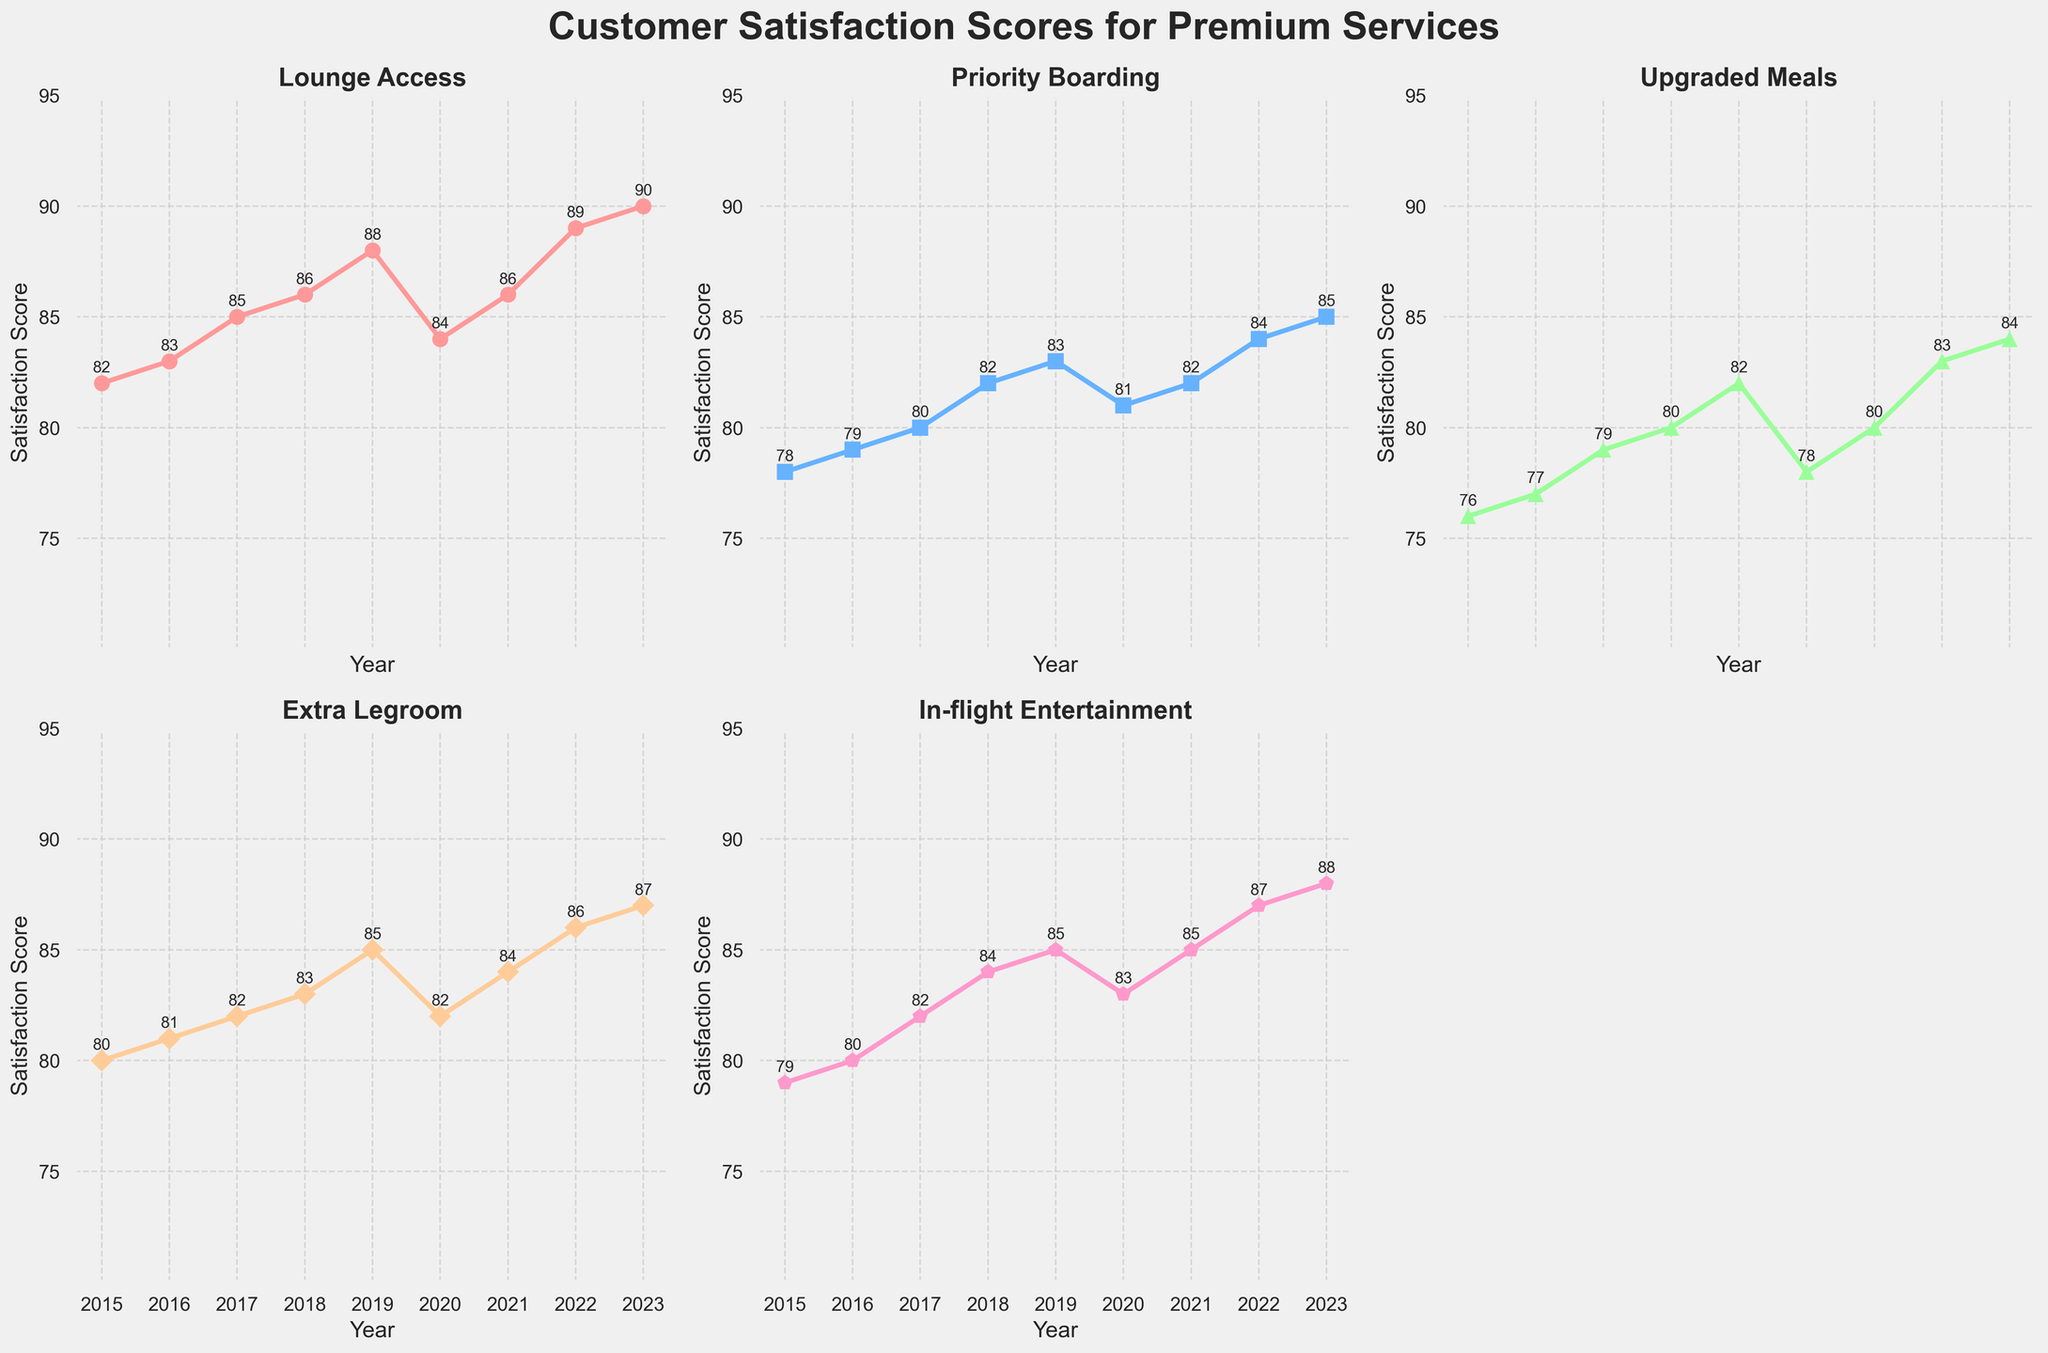What's the highest customer satisfaction score achieved for Lounge Access? In the chart, find the plot for Lounge Access and look for the highest point over the years. The highest customer satisfaction score for Lounge Access is labeled as 90 in 2023.
Answer: 90 How did the customer satisfaction score for Priority Boarding change from 2019 to 2020? In the chart, locate the Priority Boarding plot. Find the score for the years 2019 and 2020. The score decreased from 83 in 2019 to 81 in 2020.
Answer: Decreased by 2 Which premium service had the highest improvement in customer satisfaction score between 2015 and 2023? Check the starting and ending scores for each service from 2015 to 2023. Calculate the improvement for each service: Lounge Access (90-82=8), Priority Boarding (85-78=7), Upgraded Meals (84-76=8), Extra Legroom (87-80=7), In-flight Entertainment (88-79=9). The highest improvement is for In-flight Entertainment.
Answer: In-flight Entertainment In which year did Extra Legroom see the lowest satisfaction score? Identify the Extra Legroom plot and look for the lowest point in the chart. The lowest satisfaction score for Extra Legroom is 80 in 2015.
Answer: 2015 Which two services had the closest customer satisfaction scores in 2017? Locate the satisfaction scores for all services in 2017. Check differences between them: Lounge Access (85), Priority Boarding (80), Upgraded Meals (79), Extra Legroom (82), In-flight Entertainment (82). The closest scores are for Extra Legroom and In-flight Entertainment, both at 82.
Answer: Extra Legroom and In-flight Entertainment What is the average customer satisfaction score for Upgraded Meals between 2015 and 2023? Add the satisfaction scores for Upgraded Meals over the years: 76+77+79+80+82+78+80+83+84 = 719. Count the number of years: 9. Divide the total by the number of years: 719/9 ≈ 79.9.
Answer: 79.9 Which year saw the highest overall satisfaction score in the combined services? Sum the satisfaction scores of all services for each year and compare. For example, 2023: 90+85+84+87+88 = 434. The highest total satisfaction is in 2023.
Answer: 2023 How many services achieved a satisfaction score above 85 in 2022? Check each service's satisfaction score in 2022: Lounge Access (89), Priority Boarding (84), Upgraded Meals (83), Extra Legroom (86), In-flight Entertainment (87). Count the number of services above 85: 3 services (Lounge Access, Extra Legroom, In-flight Entertainment).
Answer: 3 What's the difference between the customer satisfaction scores for Priority Boarding and Upgraded Meals in 2023? Locate the satisfaction scores for both services in 2023: Priority Boarding (85) and Upgraded Meals (84). Subtract the latter from the former: 85 - 84 = 1.
Answer: 1 Which service showed a declining trend in customer satisfaction score from 2019 to 2020 and then recovered by 2022? Identify the trends for each service from 2019 to 2022. Extra Legroom declines from 85 to 82 in 2020 and then recovers to 86 in 2022. This applies to Extra Legroom.
Answer: Extra Legroom 